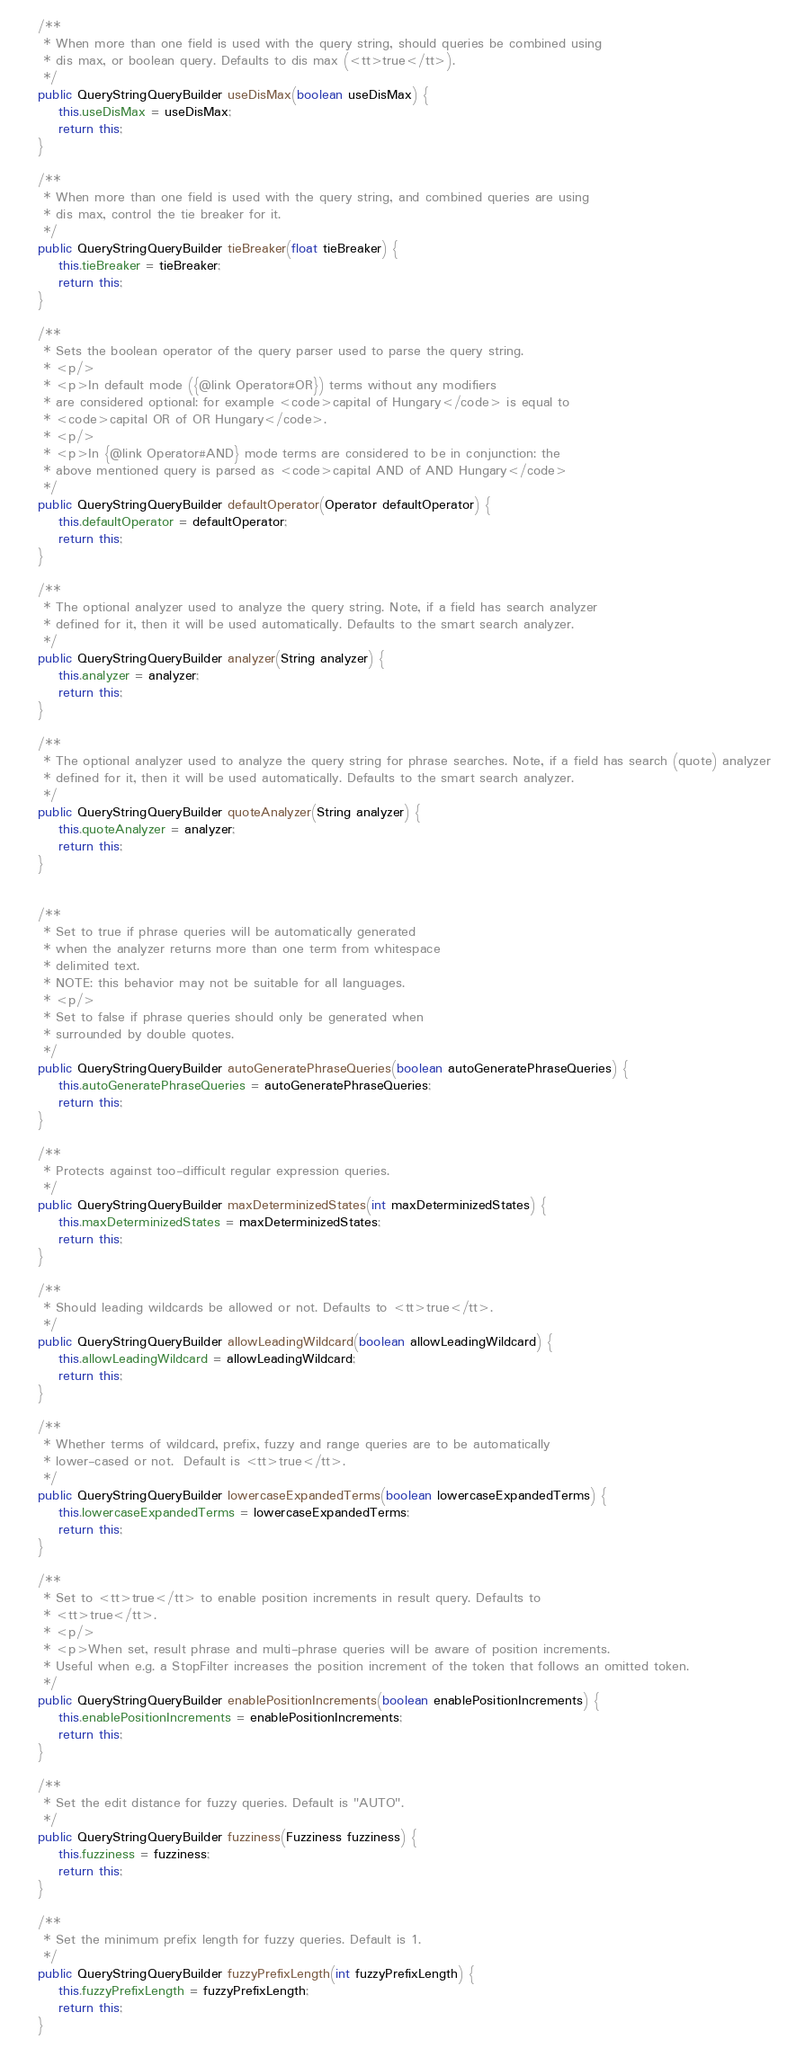Convert code to text. <code><loc_0><loc_0><loc_500><loc_500><_Java_>    /**
     * When more than one field is used with the query string, should queries be combined using
     * dis max, or boolean query. Defaults to dis max (<tt>true</tt>).
     */
    public QueryStringQueryBuilder useDisMax(boolean useDisMax) {
        this.useDisMax = useDisMax;
        return this;
    }

    /**
     * When more than one field is used with the query string, and combined queries are using
     * dis max, control the tie breaker for it.
     */
    public QueryStringQueryBuilder tieBreaker(float tieBreaker) {
        this.tieBreaker = tieBreaker;
        return this;
    }

    /**
     * Sets the boolean operator of the query parser used to parse the query string.
     * <p/>
     * <p>In default mode ({@link Operator#OR}) terms without any modifiers
     * are considered optional: for example <code>capital of Hungary</code> is equal to
     * <code>capital OR of OR Hungary</code>.
     * <p/>
     * <p>In {@link Operator#AND} mode terms are considered to be in conjunction: the
     * above mentioned query is parsed as <code>capital AND of AND Hungary</code>
     */
    public QueryStringQueryBuilder defaultOperator(Operator defaultOperator) {
        this.defaultOperator = defaultOperator;
        return this;
    }

    /**
     * The optional analyzer used to analyze the query string. Note, if a field has search analyzer
     * defined for it, then it will be used automatically. Defaults to the smart search analyzer.
     */
    public QueryStringQueryBuilder analyzer(String analyzer) {
        this.analyzer = analyzer;
        return this;
    }

    /**
     * The optional analyzer used to analyze the query string for phrase searches. Note, if a field has search (quote) analyzer
     * defined for it, then it will be used automatically. Defaults to the smart search analyzer.
     */
    public QueryStringQueryBuilder quoteAnalyzer(String analyzer) {
        this.quoteAnalyzer = analyzer;
        return this;
    }


    /**
     * Set to true if phrase queries will be automatically generated
     * when the analyzer returns more than one term from whitespace
     * delimited text.
     * NOTE: this behavior may not be suitable for all languages.
     * <p/>
     * Set to false if phrase queries should only be generated when
     * surrounded by double quotes.
     */
    public QueryStringQueryBuilder autoGeneratePhraseQueries(boolean autoGeneratePhraseQueries) {
        this.autoGeneratePhraseQueries = autoGeneratePhraseQueries;
        return this;
    }

    /**
     * Protects against too-difficult regular expression queries.
     */
    public QueryStringQueryBuilder maxDeterminizedStates(int maxDeterminizedStates) {
        this.maxDeterminizedStates = maxDeterminizedStates;
        return this;
    }

    /**
     * Should leading wildcards be allowed or not. Defaults to <tt>true</tt>.
     */
    public QueryStringQueryBuilder allowLeadingWildcard(boolean allowLeadingWildcard) {
        this.allowLeadingWildcard = allowLeadingWildcard;
        return this;
    }

    /**
     * Whether terms of wildcard, prefix, fuzzy and range queries are to be automatically
     * lower-cased or not.  Default is <tt>true</tt>.
     */
    public QueryStringQueryBuilder lowercaseExpandedTerms(boolean lowercaseExpandedTerms) {
        this.lowercaseExpandedTerms = lowercaseExpandedTerms;
        return this;
    }

    /**
     * Set to <tt>true</tt> to enable position increments in result query. Defaults to
     * <tt>true</tt>.
     * <p/>
     * <p>When set, result phrase and multi-phrase queries will be aware of position increments.
     * Useful when e.g. a StopFilter increases the position increment of the token that follows an omitted token.
     */
    public QueryStringQueryBuilder enablePositionIncrements(boolean enablePositionIncrements) {
        this.enablePositionIncrements = enablePositionIncrements;
        return this;
    }

    /**
     * Set the edit distance for fuzzy queries. Default is "AUTO".
     */
    public QueryStringQueryBuilder fuzziness(Fuzziness fuzziness) {
        this.fuzziness = fuzziness;
        return this;
    }

    /**
     * Set the minimum prefix length for fuzzy queries. Default is 1.
     */
    public QueryStringQueryBuilder fuzzyPrefixLength(int fuzzyPrefixLength) {
        this.fuzzyPrefixLength = fuzzyPrefixLength;
        return this;
    }
</code> 